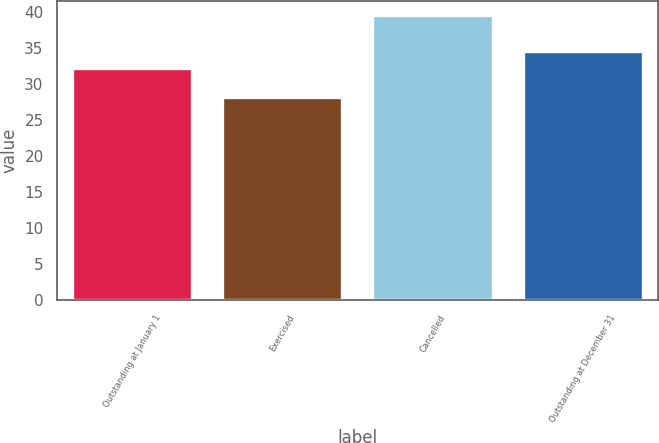<chart> <loc_0><loc_0><loc_500><loc_500><bar_chart><fcel>Outstanding at January 1<fcel>Exercised<fcel>Cancelled<fcel>Outstanding at December 31<nl><fcel>32.25<fcel>28.17<fcel>39.64<fcel>34.6<nl></chart> 